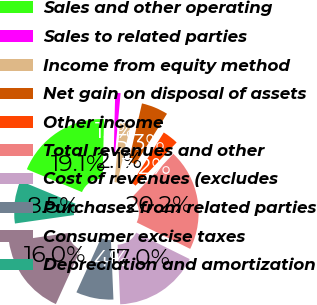Convert chart to OTSL. <chart><loc_0><loc_0><loc_500><loc_500><pie_chart><fcel>Sales and other operating<fcel>Sales to related parties<fcel>Income from equity method<fcel>Net gain on disposal of assets<fcel>Other income<fcel>Total revenues and other<fcel>Cost of revenues (excludes<fcel>Purchases from related parties<fcel>Consumer excise taxes<fcel>Depreciation and amortization<nl><fcel>19.15%<fcel>1.06%<fcel>2.13%<fcel>5.32%<fcel>3.19%<fcel>20.21%<fcel>17.02%<fcel>7.45%<fcel>15.96%<fcel>8.51%<nl></chart> 